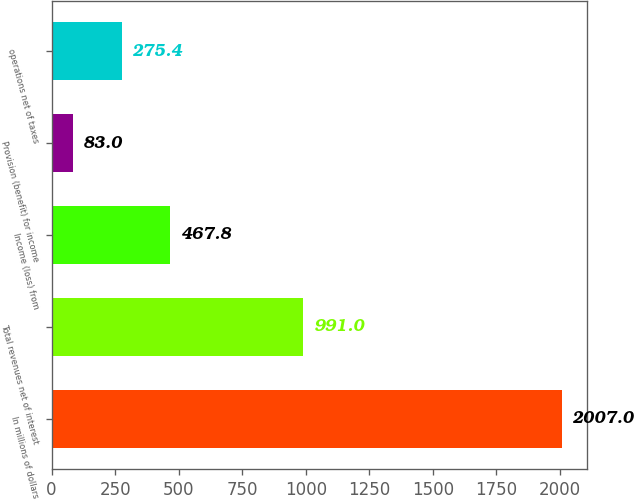<chart> <loc_0><loc_0><loc_500><loc_500><bar_chart><fcel>In millions of dollars<fcel>Total revenues net of interest<fcel>Income (loss) from<fcel>Provision (benefit) for income<fcel>operations net of taxes<nl><fcel>2007<fcel>991<fcel>467.8<fcel>83<fcel>275.4<nl></chart> 